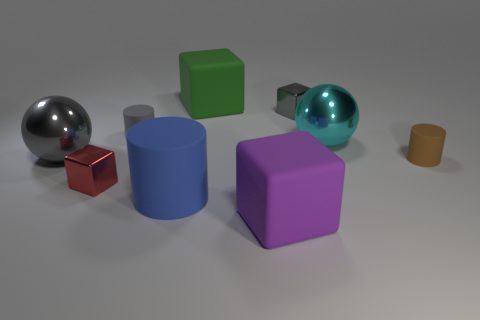Subtract all cyan spheres. How many spheres are left? 1 Subtract all cylinders. How many objects are left? 6 Subtract 3 cylinders. How many cylinders are left? 0 Subtract all green cylinders. Subtract all brown balls. How many cylinders are left? 3 Subtract all green cylinders. How many brown balls are left? 0 Subtract all large gray shiny spheres. Subtract all balls. How many objects are left? 6 Add 9 brown things. How many brown things are left? 10 Add 9 green rubber objects. How many green rubber objects exist? 10 Add 1 cylinders. How many objects exist? 10 Subtract all small matte cylinders. How many cylinders are left? 1 